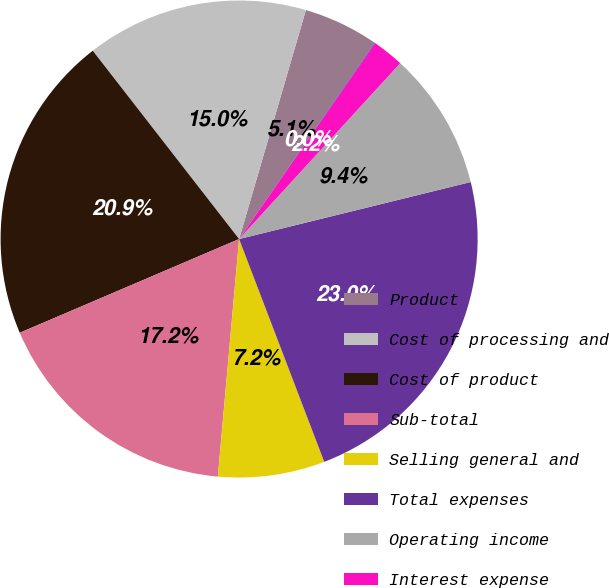Convert chart. <chart><loc_0><loc_0><loc_500><loc_500><pie_chart><fcel>Product<fcel>Cost of processing and<fcel>Cost of product<fcel>Sub-total<fcel>Selling general and<fcel>Total expenses<fcel>Operating income<fcel>Interest expense<fcel>Interest and investment income<nl><fcel>5.11%<fcel>15.03%<fcel>20.91%<fcel>17.15%<fcel>7.23%<fcel>23.03%<fcel>9.35%<fcel>2.15%<fcel>0.03%<nl></chart> 